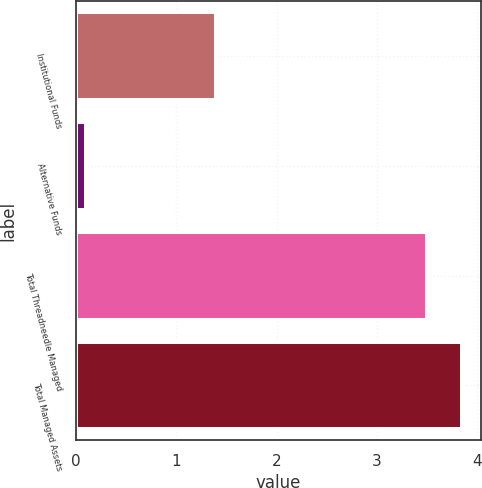<chart> <loc_0><loc_0><loc_500><loc_500><bar_chart><fcel>Institutional Funds<fcel>Alternative Funds<fcel>Total Threadneedle Managed<fcel>Total Managed Assets<nl><fcel>1.4<fcel>0.1<fcel>3.5<fcel>3.85<nl></chart> 